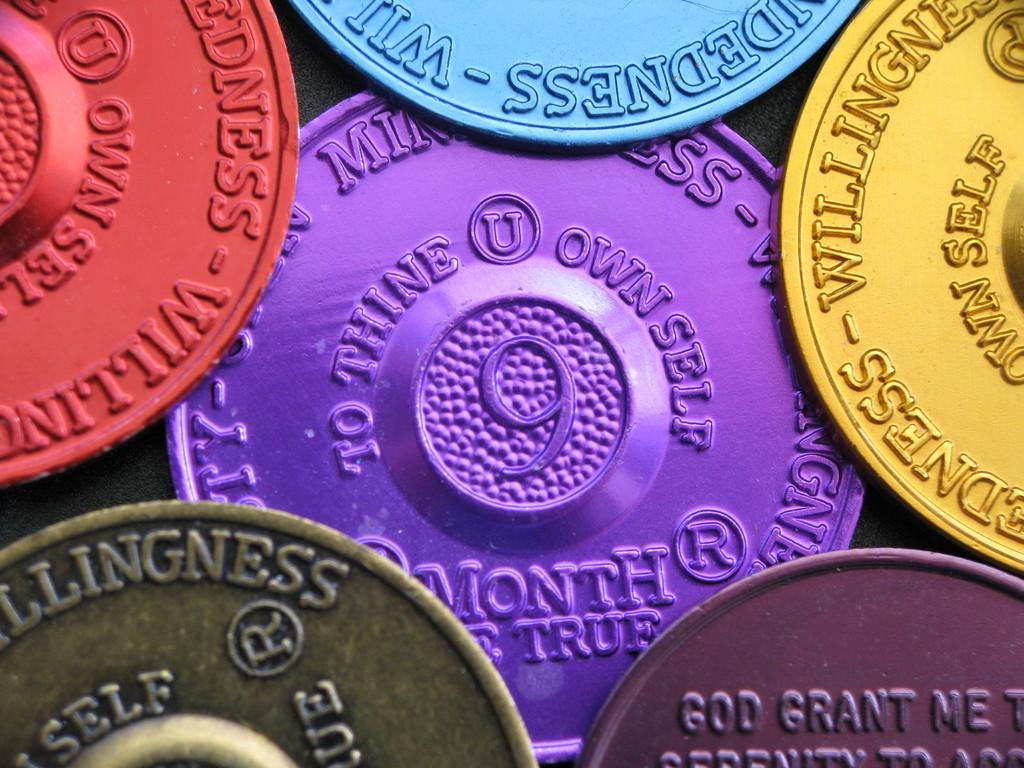<image>
Render a clear and concise summary of the photo. A handful of multicolored tokens bear self-help inscriptions like "to thine own self". 